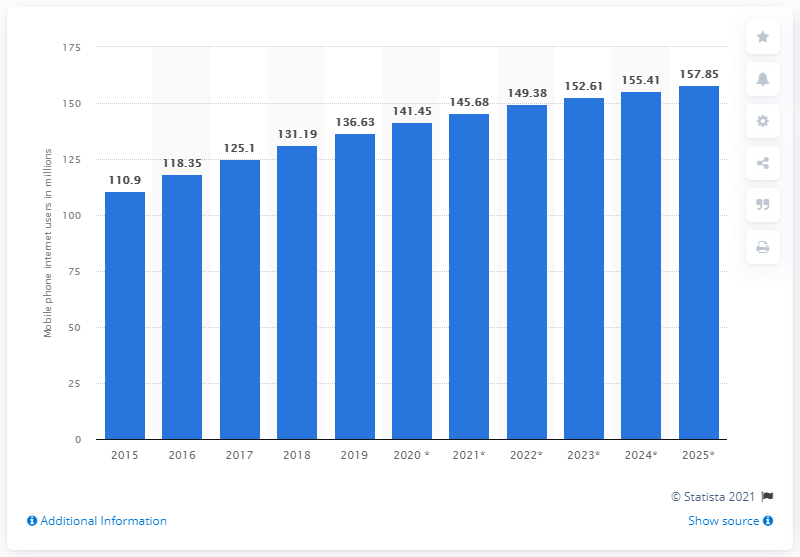Highlight a few significant elements in this photo. In 2015, there were 110.9 million mobile phone users in Brazil. By the end of 2020, it is projected that there will be approximately 141.45 million Brazilian mobile phone users who will access the internet from their devices. 